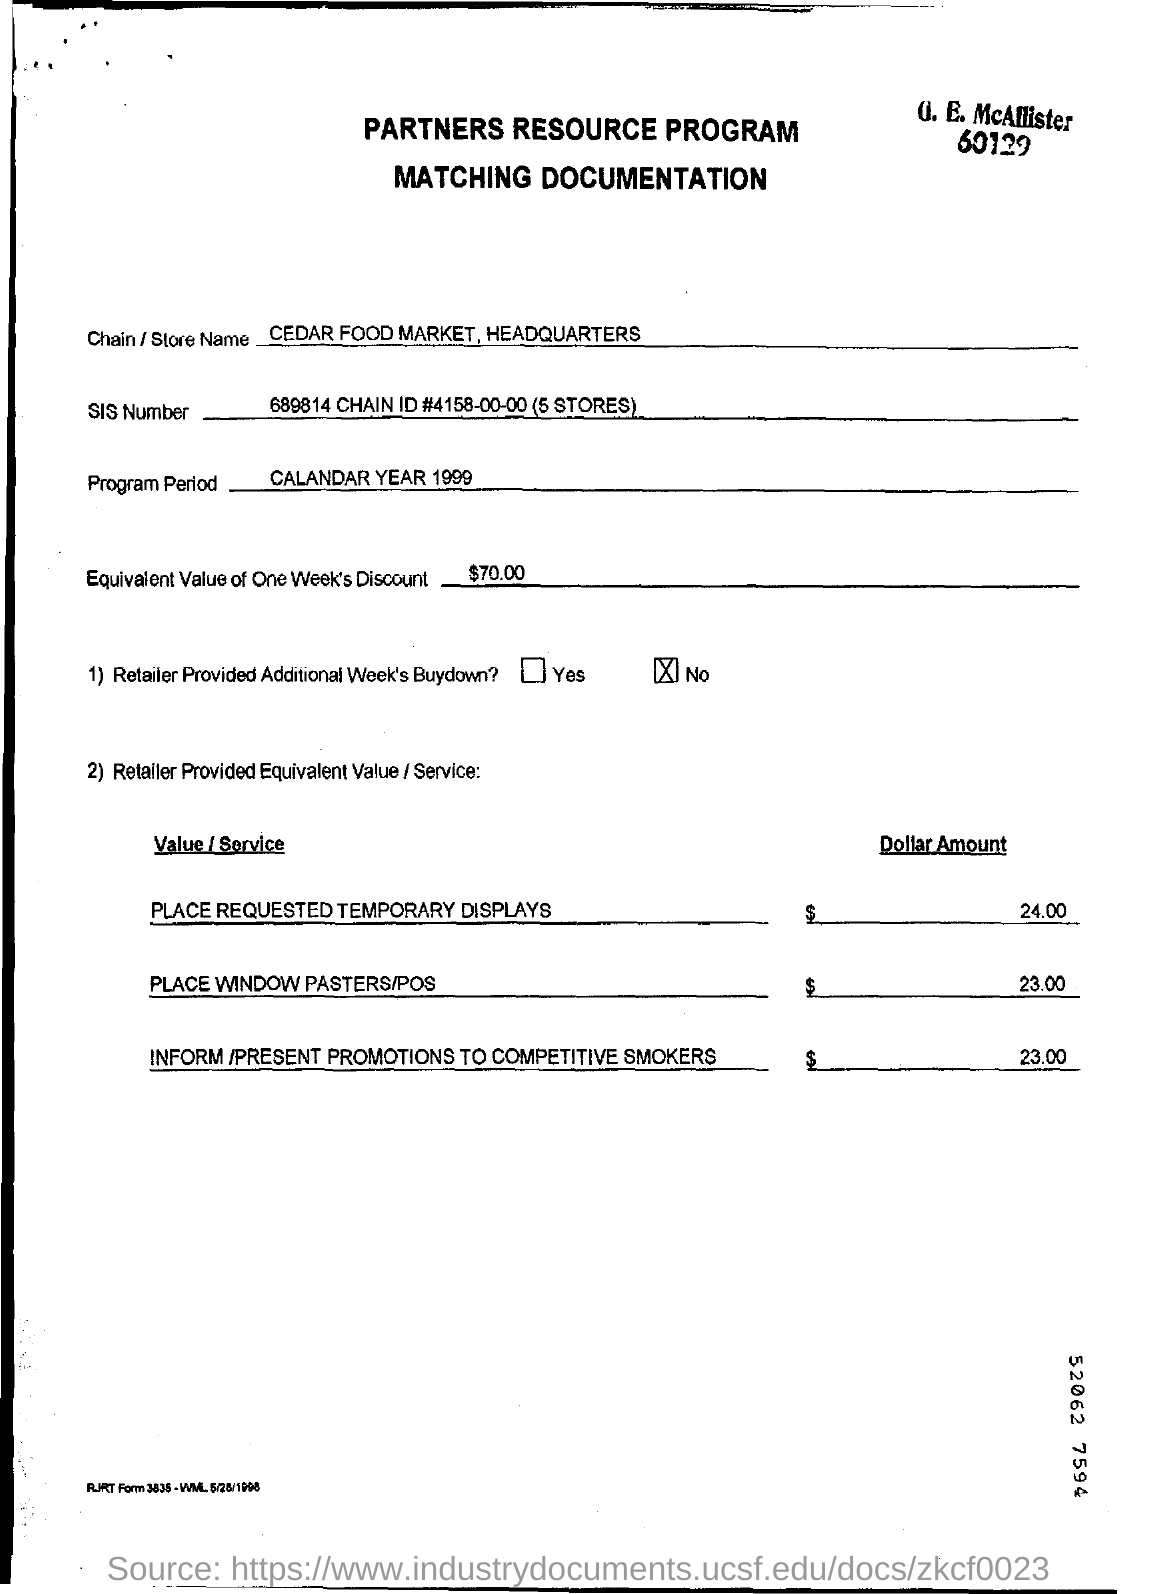What is the Store Name?
Ensure brevity in your answer.  CEDAR FOOD MARKET, HEADQUARTERS. How much equivalent value of one week's discount ?
Your answer should be compact. $70.00. What is the SIS Number ?
Provide a short and direct response. 689814. 